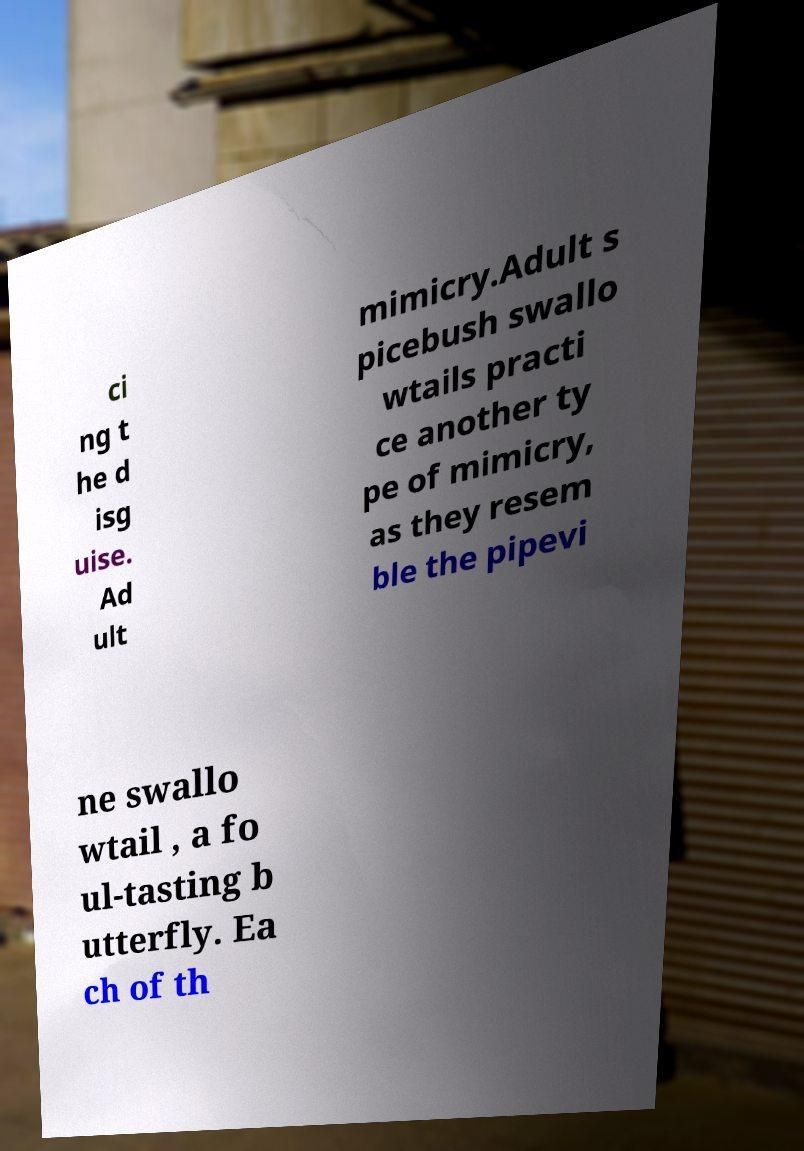Could you assist in decoding the text presented in this image and type it out clearly? ci ng t he d isg uise. Ad ult mimicry.Adult s picebush swallo wtails practi ce another ty pe of mimicry, as they resem ble the pipevi ne swallo wtail , a fo ul-tasting b utterfly. Ea ch of th 